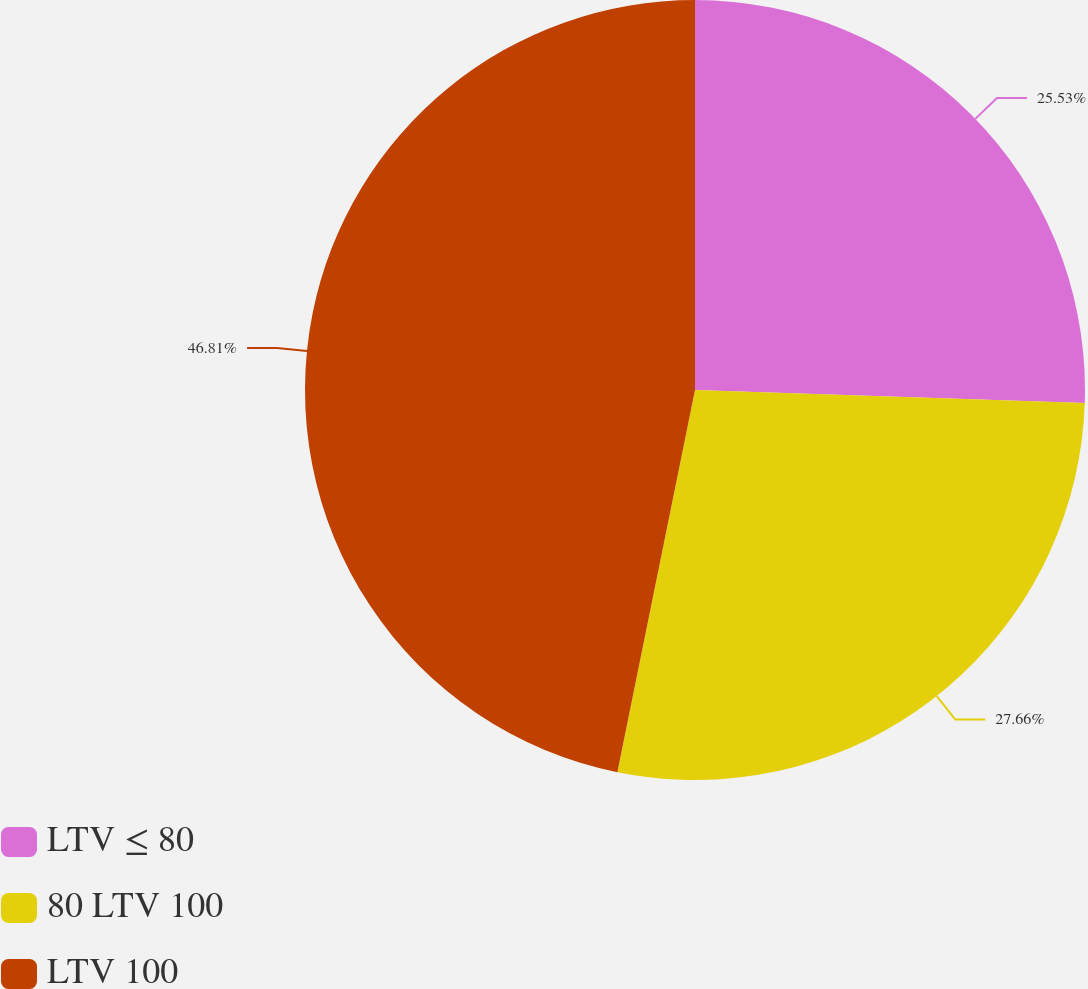Convert chart to OTSL. <chart><loc_0><loc_0><loc_500><loc_500><pie_chart><fcel>LTV ≤ 80<fcel>80 LTV 100<fcel>LTV 100<nl><fcel>25.53%<fcel>27.66%<fcel>46.81%<nl></chart> 